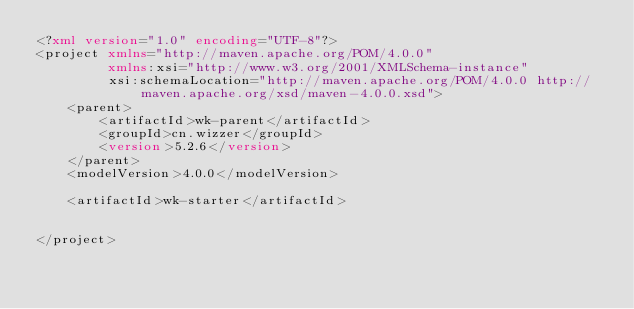Convert code to text. <code><loc_0><loc_0><loc_500><loc_500><_XML_><?xml version="1.0" encoding="UTF-8"?>
<project xmlns="http://maven.apache.org/POM/4.0.0"
         xmlns:xsi="http://www.w3.org/2001/XMLSchema-instance"
         xsi:schemaLocation="http://maven.apache.org/POM/4.0.0 http://maven.apache.org/xsd/maven-4.0.0.xsd">
    <parent>
        <artifactId>wk-parent</artifactId>
        <groupId>cn.wizzer</groupId>
        <version>5.2.6</version>
    </parent>
    <modelVersion>4.0.0</modelVersion>

    <artifactId>wk-starter</artifactId>


</project></code> 